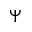Convert formula to latex. <formula><loc_0><loc_0><loc_500><loc_500>\Psi</formula> 